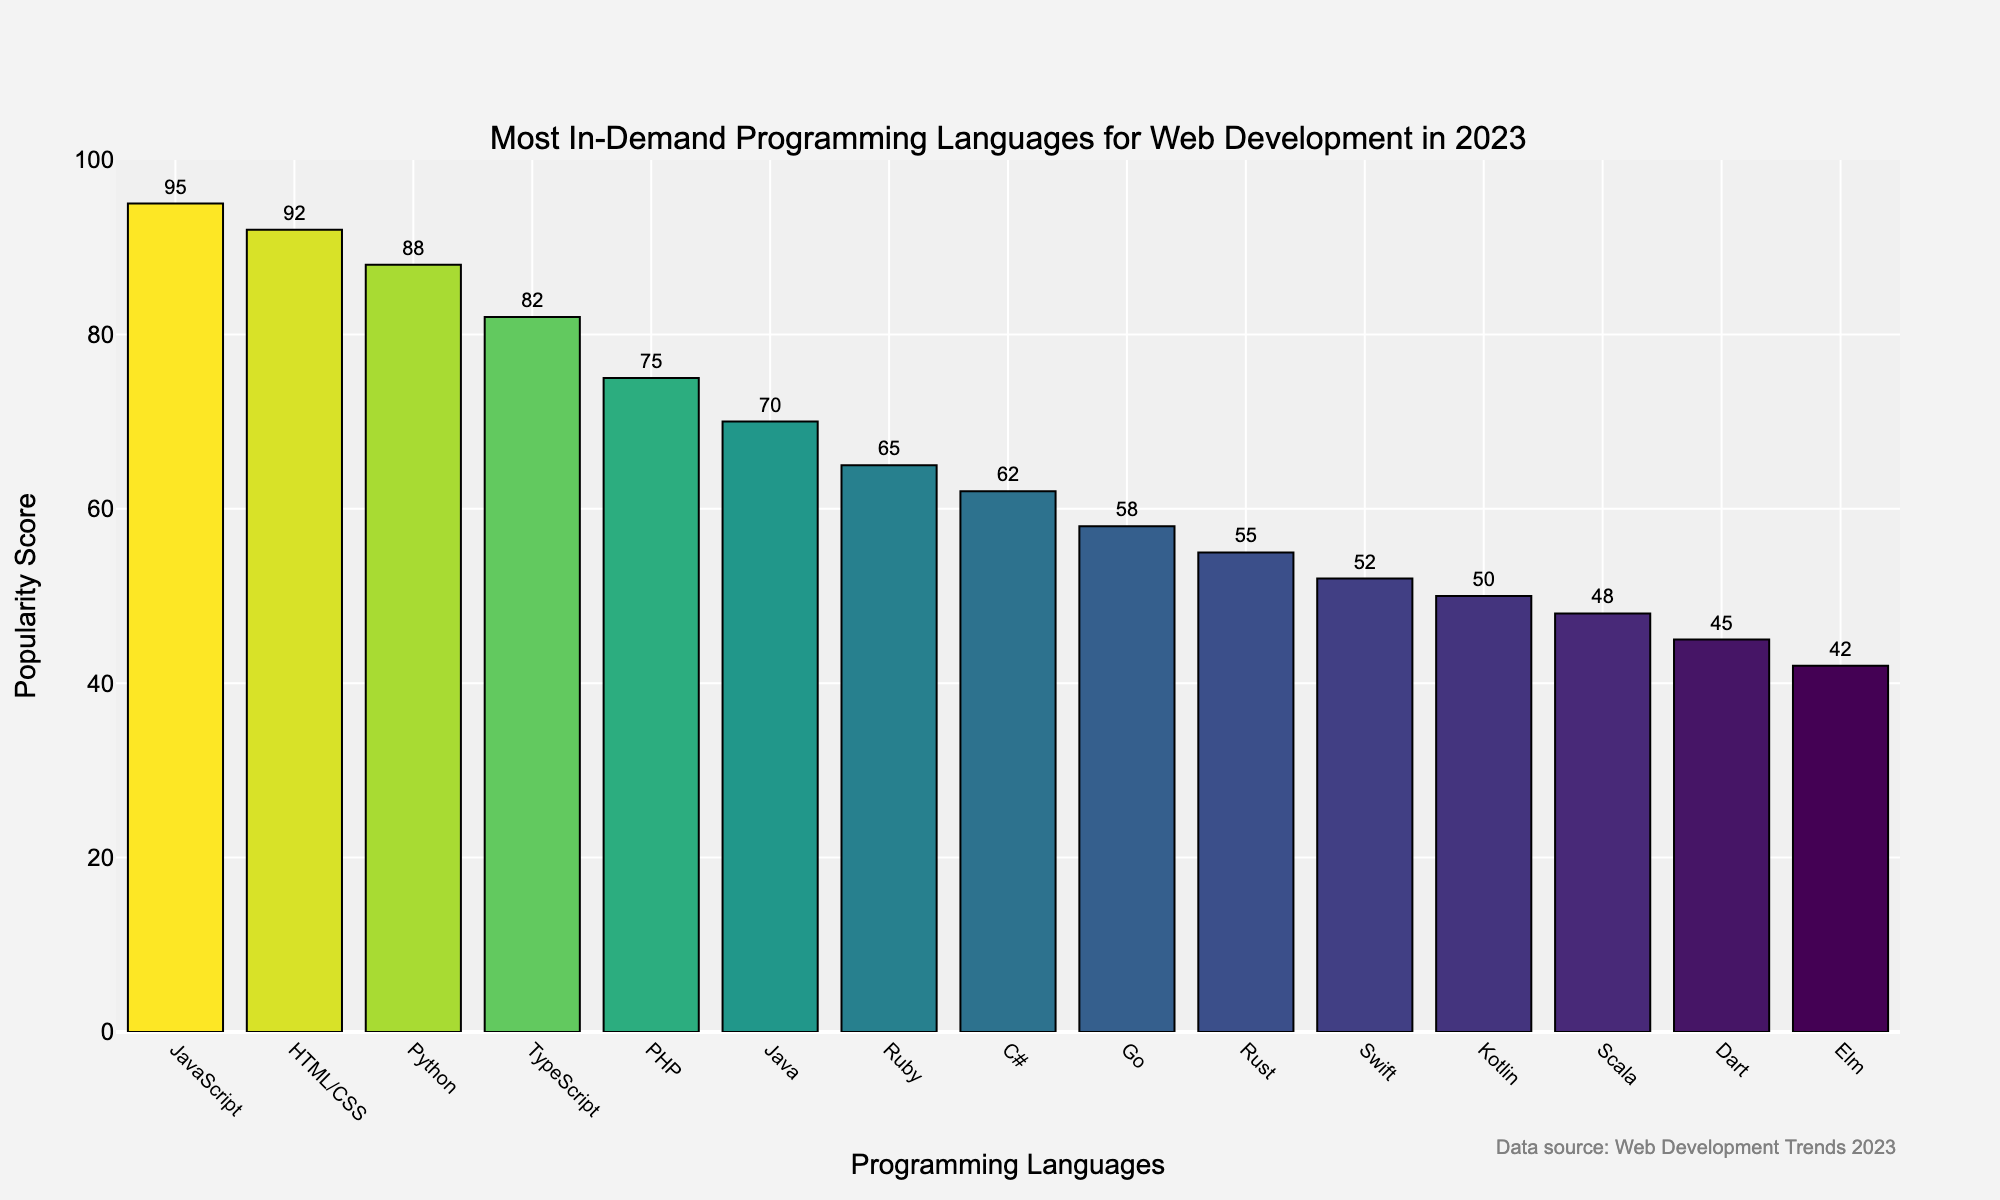What is the most in-demand programming language for web development in 2023? The bar chart shows the popularity scores of various programming languages. The language with the highest score is JavaScript with a score of 95, indicating it is the most in-demand.
Answer: JavaScript Which programming language has a higher popularity score, Python or PHP? By comparing the heights of the bars and the scores associated with them, Python has a popularity score of 88, while PHP has a score of 75. Therefore, Python has a higher score.
Answer: Python What is the total popularity score for Java, Ruby, and Go? Add the popularity scores of the individual languages: Java (70), Ruby (65), and Go (58). Sum = 70 + 65 + 58 = 193.
Answer: 193 Which language has the lowest popularity score in 2023? By looking at the bar heights, the shortest bar corresponds to Elm with a popularity score of 42, making it the least popular language on the list.
Answer: Elm How much more popular is JavaScript compared to Rust? JavaScript has a popularity score of 95, while Rust has a score of 55. The difference is calculated as 95 - 55 = 40.
Answer: 40 List the top three languages in terms of popularity score. From the chart, the top three languages with the highest popularity scores are JavaScript (95), HTML/CSS (92), and Python (88).
Answer: JavaScript, HTML/CSS, Python What is the average popularity score of TypeScript and Swift? Add the scores of TypeScript (82) and Swift (52) and then divide by 2. Hence, (82 + 52) / 2 = 134 / 2 = 67.
Answer: 67 Are there any programming languages with a popularity score between 50 and 60? If so, which ones? Observing the bar chart, the languages with scores between 50 and 60 are Rust (55) and Go (58).
Answer: Rust, Go Which language has a higher popularity score, Kotlin or Scala? By looking at the respective bars, Kotlin has a score of 50 and Scala has a score of 48. Therefore, Kotlin has a higher popularity score.
Answer: Kotlin What is the combined popularity score of all the languages with scores greater than 80? Adding the scores of JavaScript (95), HTML/CSS (92), Python (88), and TypeScript (82): 95 + 92 + 88 + 82 = 357.
Answer: 357 